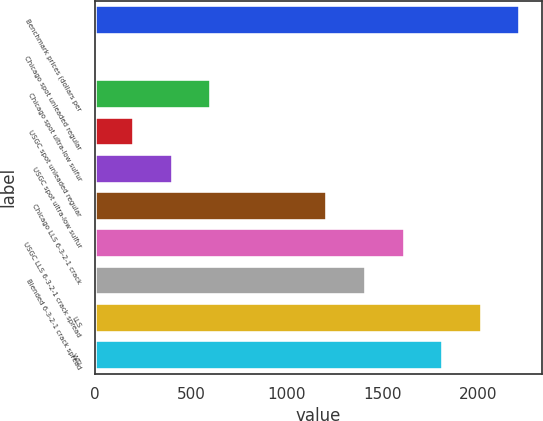Convert chart. <chart><loc_0><loc_0><loc_500><loc_500><bar_chart><fcel>Benchmark prices (dollars per<fcel>Chicago spot unleaded regular<fcel>Chicago spot ultra-low sulfur<fcel>USGC spot unleaded regular<fcel>USGC spot ultra-low sulfur<fcel>Chicago LLS 6-3-2-1 crack<fcel>USGC LLS 6-3-2-1 crack spread<fcel>Blended 6-3-2-1 crack spread<fcel>LLS<fcel>WTI<nl><fcel>2218.52<fcel>1.58<fcel>606.2<fcel>203.12<fcel>404.66<fcel>1210.82<fcel>1613.9<fcel>1412.36<fcel>2016.98<fcel>1815.44<nl></chart> 